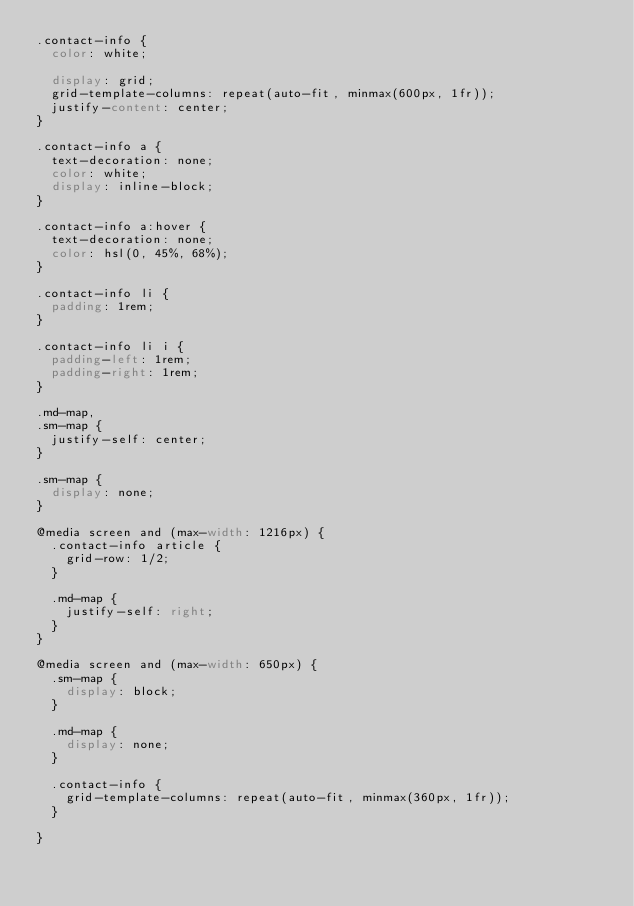Convert code to text. <code><loc_0><loc_0><loc_500><loc_500><_CSS_>.contact-info {
  color: white;

  display: grid;
  grid-template-columns: repeat(auto-fit, minmax(600px, 1fr));
  justify-content: center;
}

.contact-info a {
  text-decoration: none;
  color: white;
  display: inline-block;
}

.contact-info a:hover {
  text-decoration: none;
  color: hsl(0, 45%, 68%);
}

.contact-info li {
  padding: 1rem;
}

.contact-info li i {
  padding-left: 1rem;
  padding-right: 1rem;
}

.md-map,
.sm-map {
  justify-self: center;
}

.sm-map {
  display: none;
}

@media screen and (max-width: 1216px) {
  .contact-info article {
    grid-row: 1/2;
  }

  .md-map {
    justify-self: right;
  }
}

@media screen and (max-width: 650px) {
  .sm-map {
    display: block;
  }

  .md-map {
    display: none;
  }

  .contact-info {
    grid-template-columns: repeat(auto-fit, minmax(360px, 1fr));
  }

}</code> 